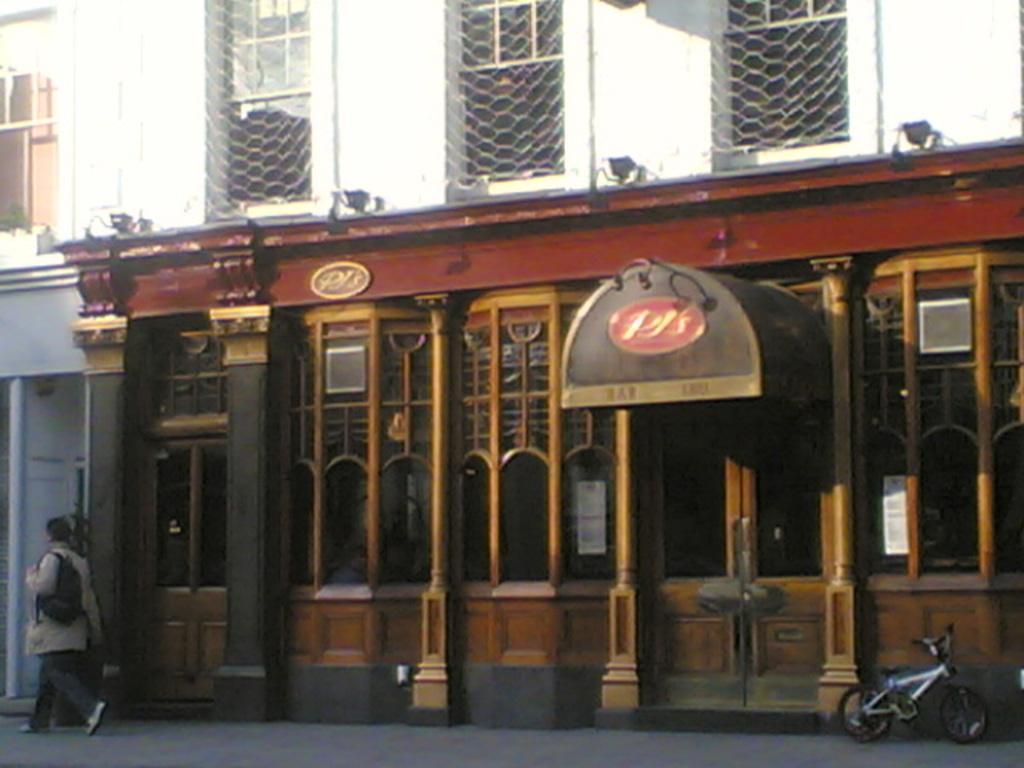Can you describe this image briefly? This picture shows a building and we see a bicycle powered on the sidewalk human walking holding a bag. 